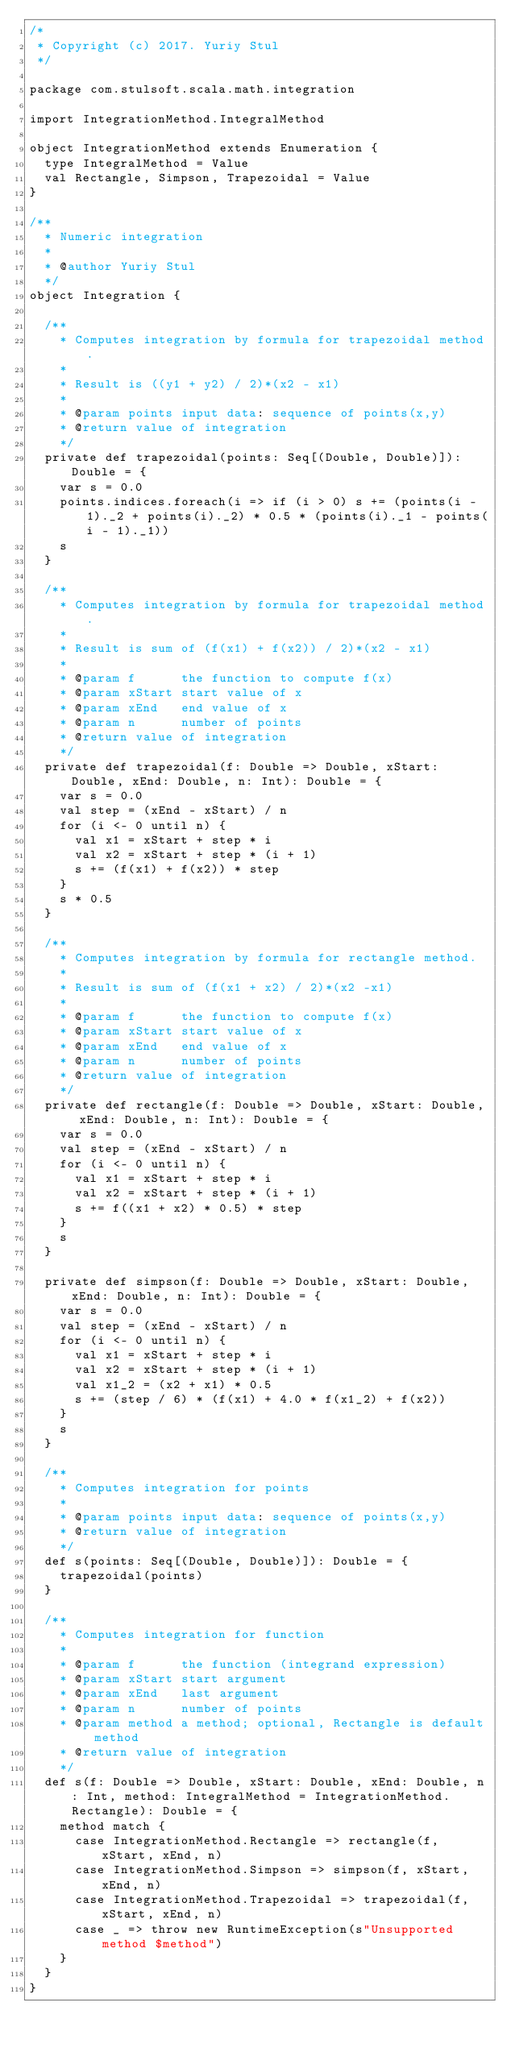<code> <loc_0><loc_0><loc_500><loc_500><_Scala_>/*
 * Copyright (c) 2017. Yuriy Stul
 */

package com.stulsoft.scala.math.integration

import IntegrationMethod.IntegralMethod

object IntegrationMethod extends Enumeration {
  type IntegralMethod = Value
  val Rectangle, Simpson, Trapezoidal = Value
}

/**
  * Numeric integration
  *
  * @author Yuriy Stul
  */
object Integration {

  /**
    * Computes integration by formula for trapezoidal method.
    *
    * Result is ((y1 + y2) / 2)*(x2 - x1)
    *
    * @param points input data: sequence of points(x,y)
    * @return value of integration
    */
  private def trapezoidal(points: Seq[(Double, Double)]): Double = {
    var s = 0.0
    points.indices.foreach(i => if (i > 0) s += (points(i - 1)._2 + points(i)._2) * 0.5 * (points(i)._1 - points(i - 1)._1))
    s
  }

  /**
    * Computes integration by formula for trapezoidal method.
    *
    * Result is sum of (f(x1) + f(x2)) / 2)*(x2 - x1)
    *
    * @param f      the function to compute f(x)
    * @param xStart start value of x
    * @param xEnd   end value of x
    * @param n      number of points
    * @return value of integration
    */
  private def trapezoidal(f: Double => Double, xStart: Double, xEnd: Double, n: Int): Double = {
    var s = 0.0
    val step = (xEnd - xStart) / n
    for (i <- 0 until n) {
      val x1 = xStart + step * i
      val x2 = xStart + step * (i + 1)
      s += (f(x1) + f(x2)) * step
    }
    s * 0.5
  }

  /**
    * Computes integration by formula for rectangle method.
    *
    * Result is sum of (f(x1 + x2) / 2)*(x2 -x1)
    *
    * @param f      the function to compute f(x)
    * @param xStart start value of x
    * @param xEnd   end value of x
    * @param n      number of points
    * @return value of integration
    */
  private def rectangle(f: Double => Double, xStart: Double, xEnd: Double, n: Int): Double = {
    var s = 0.0
    val step = (xEnd - xStart) / n
    for (i <- 0 until n) {
      val x1 = xStart + step * i
      val x2 = xStart + step * (i + 1)
      s += f((x1 + x2) * 0.5) * step
    }
    s
  }

  private def simpson(f: Double => Double, xStart: Double, xEnd: Double, n: Int): Double = {
    var s = 0.0
    val step = (xEnd - xStart) / n
    for (i <- 0 until n) {
      val x1 = xStart + step * i
      val x2 = xStart + step * (i + 1)
      val x1_2 = (x2 + x1) * 0.5
      s += (step / 6) * (f(x1) + 4.0 * f(x1_2) + f(x2))
    }
    s
  }

  /**
    * Computes integration for points
    *
    * @param points input data: sequence of points(x,y)
    * @return value of integration
    */
  def s(points: Seq[(Double, Double)]): Double = {
    trapezoidal(points)
  }

  /**
    * Computes integration for function
    *
    * @param f      the function (integrand expression)
    * @param xStart start argument
    * @param xEnd   last argument
    * @param n      number of points
    * @param method a method; optional, Rectangle is default method
    * @return value of integration
    */
  def s(f: Double => Double, xStart: Double, xEnd: Double, n: Int, method: IntegralMethod = IntegrationMethod.Rectangle): Double = {
    method match {
      case IntegrationMethod.Rectangle => rectangle(f, xStart, xEnd, n)
      case IntegrationMethod.Simpson => simpson(f, xStart, xEnd, n)
      case IntegrationMethod.Trapezoidal => trapezoidal(f, xStart, xEnd, n)
      case _ => throw new RuntimeException(s"Unsupported method $method")
    }
  }
}
</code> 